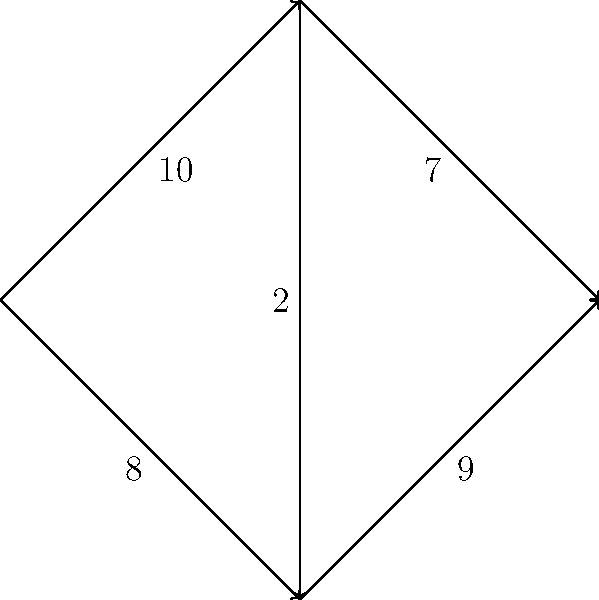Given the directed graph above representing a network flow problem, where 's' is the source and 't' is the sink, and the numbers on the edges represent their capacities, what is the maximum flow from 's' to 't'? Implement a function in Python to calculate this using the Ford-Fulkerson algorithm, and explain how you would store the graph structure in a MySQL database for efficient retrieval and updates. To solve this problem, we'll follow these steps:

1. Implement the Ford-Fulkerson algorithm in Python:
   
```python
from collections import defaultdict

def ford_fulkerson(graph, source, sink):
    def bfs(residual_graph, s, t, parent):
        visited = set()
        queue = [s]
        visited.add(s)
        while queue:
            u = queue.pop(0)
            for v in residual_graph[u]:
                if v not in visited and residual_graph[u][v] > 0:
                    queue.append(v)
                    visited.add(v)
                    parent[v] = u
                    if v == t:
                        return True
        return False

    max_flow = 0
    residual_graph = defaultdict(lambda: defaultdict(int))
    for u in graph:
        for v in graph[u]:
            residual_graph[u][v] = graph[u][v]

    parent = {}
    while bfs(residual_graph, source, sink, parent):
        path_flow = float('inf')
        s = sink
        while s != source:
            path_flow = min(path_flow, residual_graph[parent[s]][s])
            s = parent[s]
        max_flow += path_flow
        v = sink
        while v != source:
            u = parent[v]
            residual_graph[u][v] -= path_flow
            residual_graph[v][u] += path_flow
            v = parent[v]
    return max_flow

# Define the graph
graph = {
    's': {'a': 10, 'b': 8},
    'a': {'b': 2, 't': 7},
    'b': {'t': 9},
    't': {}
}

max_flow = ford_fulkerson(graph, 's', 't')
print(f"The maximum flow is: {max_flow}")
```

2. Explanation of the algorithm:
   - We use a residual graph to keep track of remaining capacities.
   - BFS is used to find augmenting paths from source to sink.
   - We repeatedly find augmenting paths and update the flow until no more paths exist.

3. Storing the graph in MySQL:
   We can use two tables to represent the graph:

   ```sql
   CREATE TABLE nodes (
       id INT PRIMARY KEY AUTO_INCREMENT,
       name VARCHAR(50) UNIQUE
   );

   CREATE TABLE edges (
       id INT PRIMARY KEY AUTO_INCREMENT,
       from_node INT,
       to_node INT,
       capacity INT,
       FOREIGN KEY (from_node) REFERENCES nodes(id),
       FOREIGN KEY (to_node) REFERENCES nodes(id)
   );
   ```

   To populate the tables:

   ```sql
   INSERT INTO nodes (name) VALUES ('s'), ('a'), ('b'), ('t');

   INSERT INTO edges (from_node, to_node, capacity) VALUES
   ((SELECT id FROM nodes WHERE name = 's'), (SELECT id FROM nodes WHERE name = 'a'), 10),
   ((SELECT id FROM nodes WHERE name = 's'), (SELECT id FROM nodes WHERE name = 'b'), 8),
   ((SELECT id FROM nodes WHERE name = 'a'), (SELECT id FROM nodes WHERE name = 'b'), 2),
   ((SELECT id FROM nodes WHERE name = 'a'), (SELECT id FROM nodes WHERE name = 't'), 7),
   ((SELECT id FROM nodes WHERE name = 'b'), (SELECT id FROM nodes WHERE name = 't'), 9);
   ```

   To retrieve the graph structure:

   ```sql
   SELECT n1.name AS from_node, n2.name AS to_node, e.capacity
   FROM edges e
   JOIN nodes n1 ON e.from_node = n1.id
   JOIN nodes n2 ON e.to_node = n2.id;
   ```

4. Running the algorithm:
   - The maximum flow is achieved by sending 7 units through s -> a -> t and 8 units through s -> b -> t.

Therefore, the maximum flow from 's' to 't' is 15 units.
Answer: 15 units 